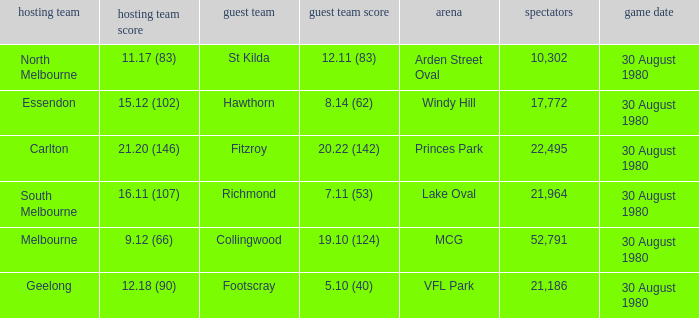What was the crowd when the away team is footscray? 21186.0. 